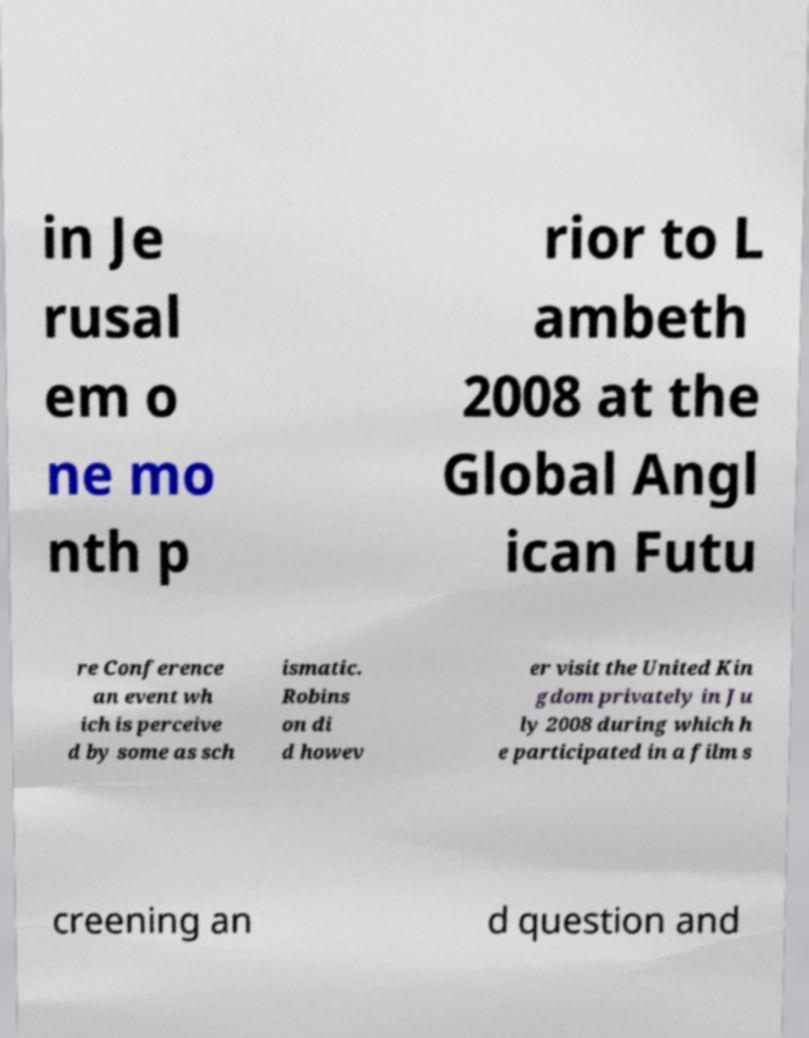Could you extract and type out the text from this image? in Je rusal em o ne mo nth p rior to L ambeth 2008 at the Global Angl ican Futu re Conference an event wh ich is perceive d by some as sch ismatic. Robins on di d howev er visit the United Kin gdom privately in Ju ly 2008 during which h e participated in a film s creening an d question and 